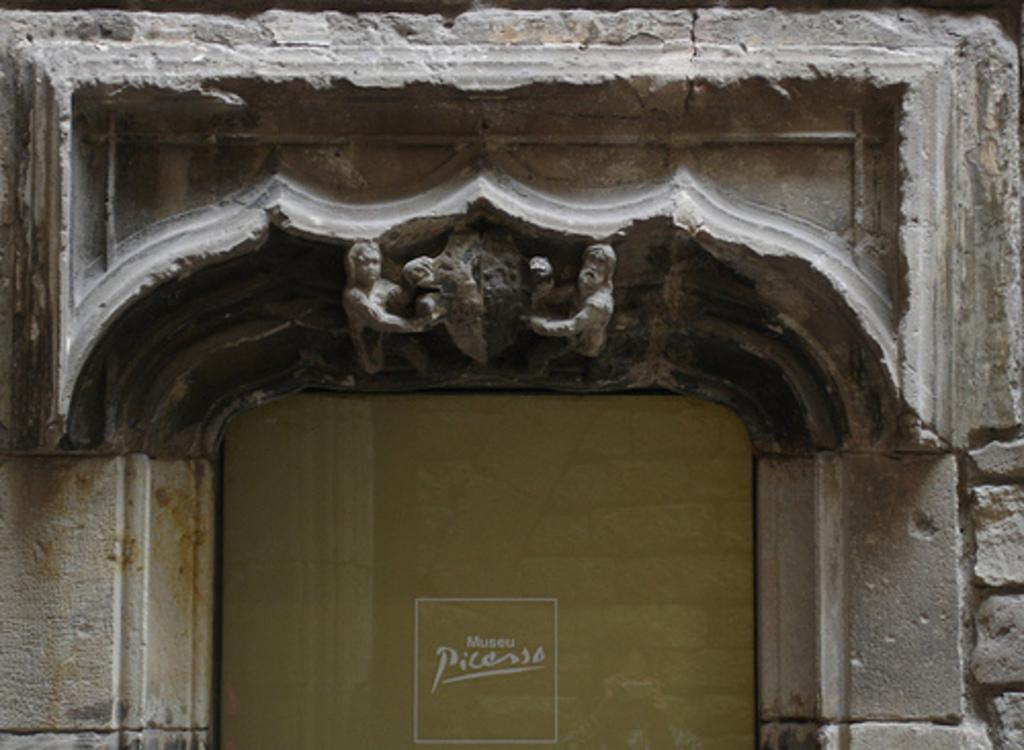What type of structure is visible in the image? There is a building in the image. What decorative elements can be seen on the wall in the foreground? There are sculptures on the wall in the foreground. Can you describe the text on a mirror in the image? There is text on a mirror at the bottom of the image. How much blood is visible on the sculptures in the image? There is no blood visible on the sculptures in the image. How many cows are present in the image? There are no cows present in the image. 